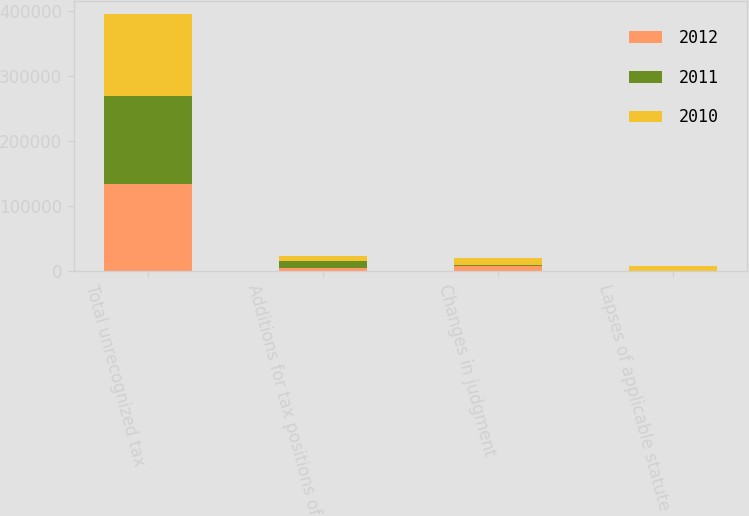Convert chart. <chart><loc_0><loc_0><loc_500><loc_500><stacked_bar_chart><ecel><fcel>Total unrecognized tax<fcel>Additions for tax positions of<fcel>Changes in judgment<fcel>Lapses of applicable statute<nl><fcel>2012<fcel>133241<fcel>5167<fcel>7729<fcel>21<nl><fcel>2011<fcel>135824<fcel>10915<fcel>1555<fcel>110<nl><fcel>2010<fcel>126698<fcel>7551<fcel>10964<fcel>7956<nl></chart> 